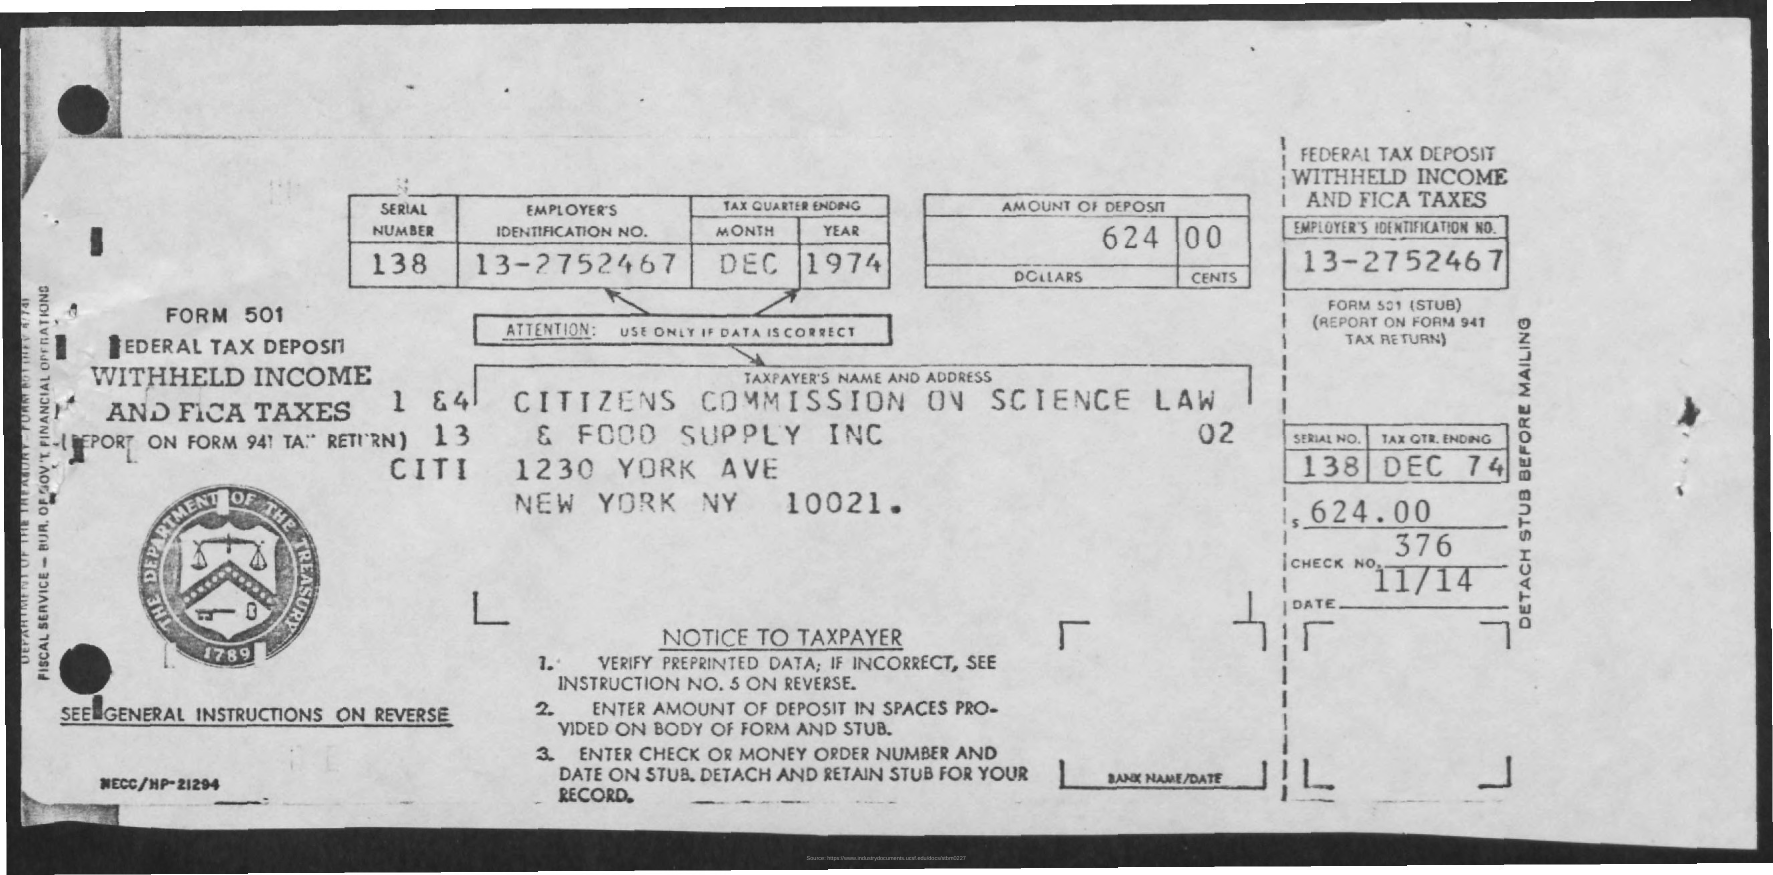Highlight a few significant elements in this photo. What is the date? It is currently 11/14... The amount of deposit is 624.00. The Employee Identification Number is a unique sequence of numbers assigned to an employee by an employer for the purpose of identification and record-keeping. The specific number is 13-2752467.. The year is 1974. December is the eleventh month of the year. 